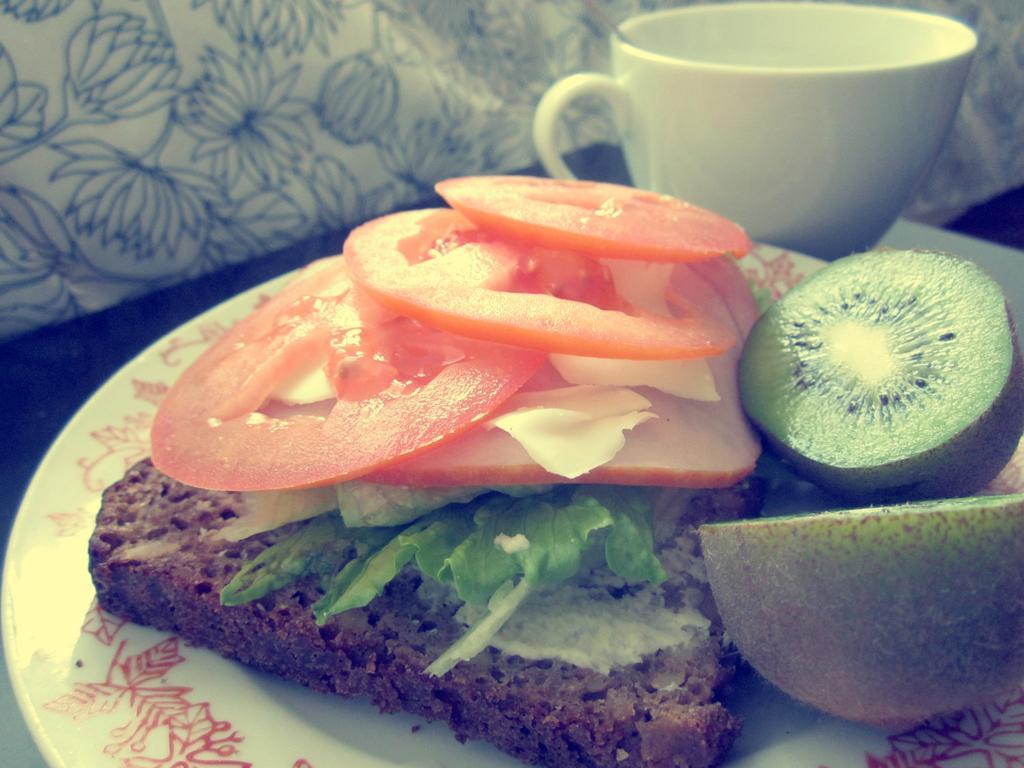How would you summarize this image in a sentence or two? In this image we can see food item on a plate and beside there is a cup and these are placed on a surface which looks like a table and we can see some other objects. 